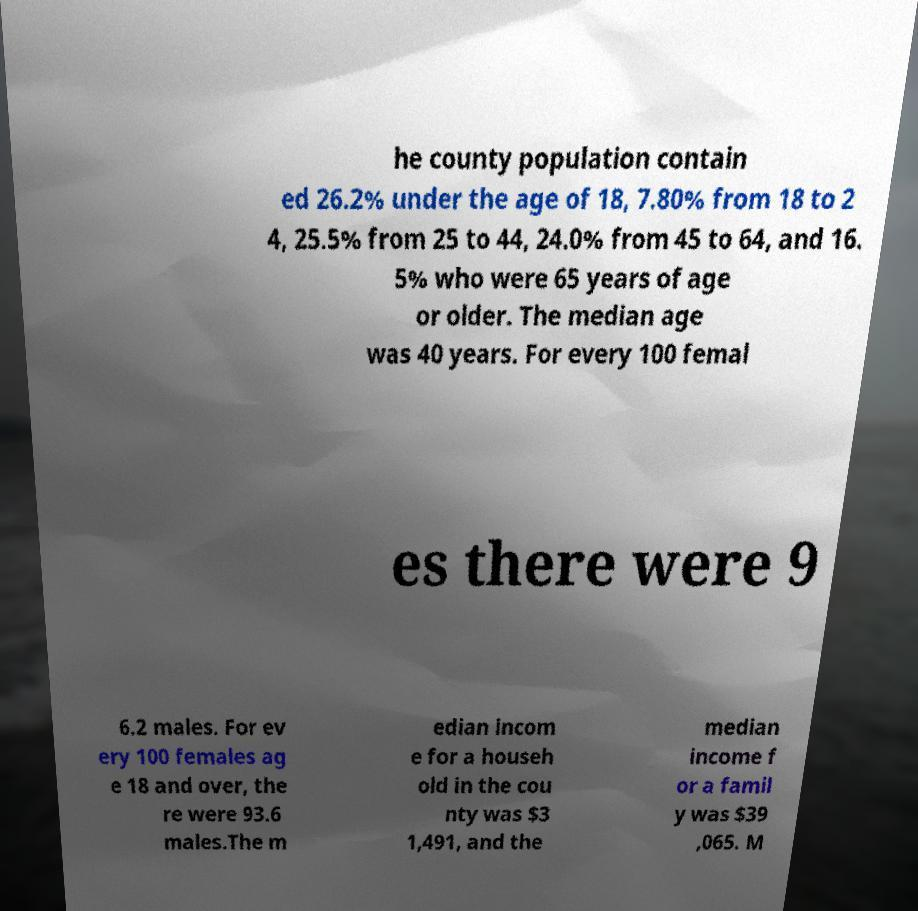I need the written content from this picture converted into text. Can you do that? he county population contain ed 26.2% under the age of 18, 7.80% from 18 to 2 4, 25.5% from 25 to 44, 24.0% from 45 to 64, and 16. 5% who were 65 years of age or older. The median age was 40 years. For every 100 femal es there were 9 6.2 males. For ev ery 100 females ag e 18 and over, the re were 93.6 males.The m edian incom e for a househ old in the cou nty was $3 1,491, and the median income f or a famil y was $39 ,065. M 